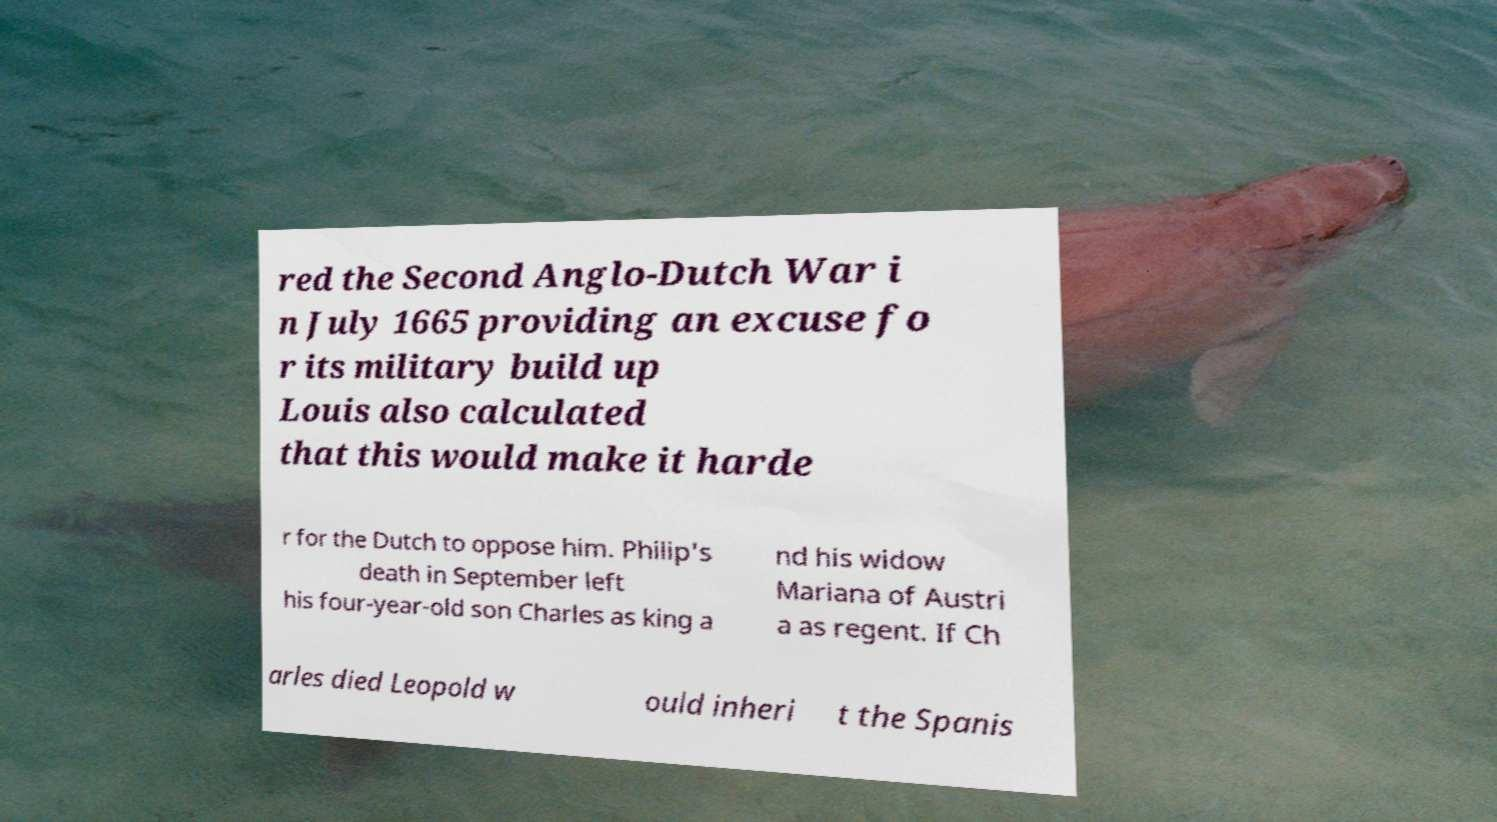Could you assist in decoding the text presented in this image and type it out clearly? red the Second Anglo-Dutch War i n July 1665 providing an excuse fo r its military build up Louis also calculated that this would make it harde r for the Dutch to oppose him. Philip's death in September left his four-year-old son Charles as king a nd his widow Mariana of Austri a as regent. If Ch arles died Leopold w ould inheri t the Spanis 